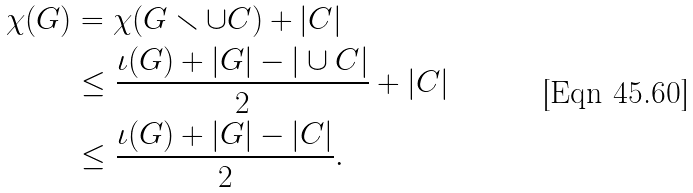Convert formula to latex. <formula><loc_0><loc_0><loc_500><loc_500>\chi ( G ) & = \chi ( G \smallsetminus \cup C ) + | C | \\ & \leq \frac { \iota ( G ) + | G | - | \cup C | } { 2 } + | C | \\ & \leq \frac { \iota ( G ) + | G | - | C | } { 2 } .</formula> 